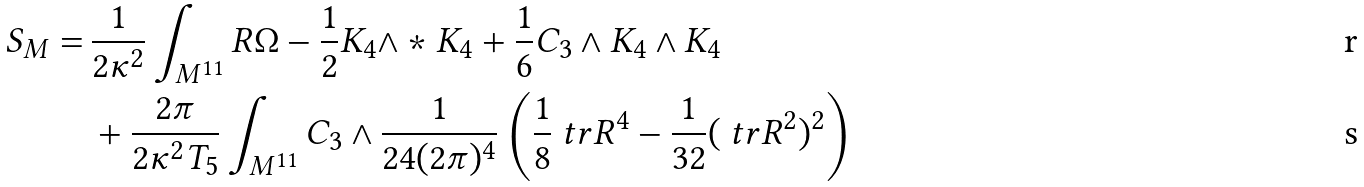<formula> <loc_0><loc_0><loc_500><loc_500>S _ { M } = \, & \frac { 1 } { 2 \kappa ^ { 2 } } \int _ { M ^ { 1 1 } } R \Omega - \frac { 1 } { 2 } K _ { 4 } \wedge * K _ { 4 } + \frac { 1 } { 6 } C _ { 3 } \wedge K _ { 4 } \wedge K _ { 4 } \\ & + \frac { 2 \pi } { 2 \kappa ^ { 2 } T _ { 5 } } \int _ { M ^ { 1 1 } } C _ { 3 } \wedge \frac { 1 } { 2 4 ( 2 \pi ) ^ { 4 } } \left ( \frac { 1 } { 8 } \ t r R ^ { 4 } - \frac { 1 } { 3 2 } ( \ t r R ^ { 2 } ) ^ { 2 } \right )</formula> 